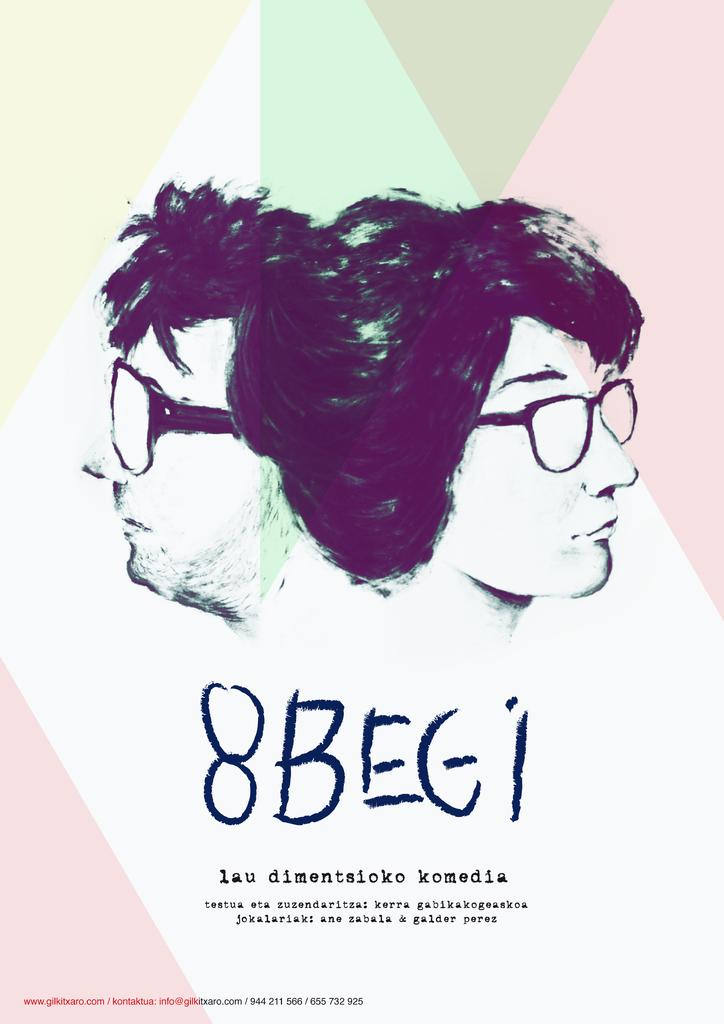What is the main subject of the image? The main subject of the image is a colorful paper. What is depicted on the paper? Two people with specs are depicted on the paper. Are there any words or text on the paper? Yes, there is writing on the paper. How many goldfish are swimming in the image? There are no goldfish present in the image; it features a colorful paper with two people with specs and writing. What type of disease is being discussed in the image? There is no discussion of any disease in the image; it only features a colorful paper with two people with specs and writing. 